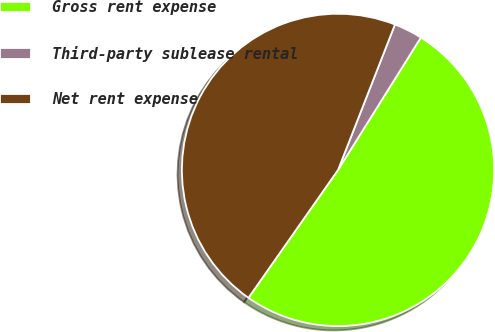Convert chart. <chart><loc_0><loc_0><loc_500><loc_500><pie_chart><fcel>Gross rent expense<fcel>Third-party sublease rental<fcel>Net rent expense<nl><fcel>50.83%<fcel>2.96%<fcel>46.21%<nl></chart> 